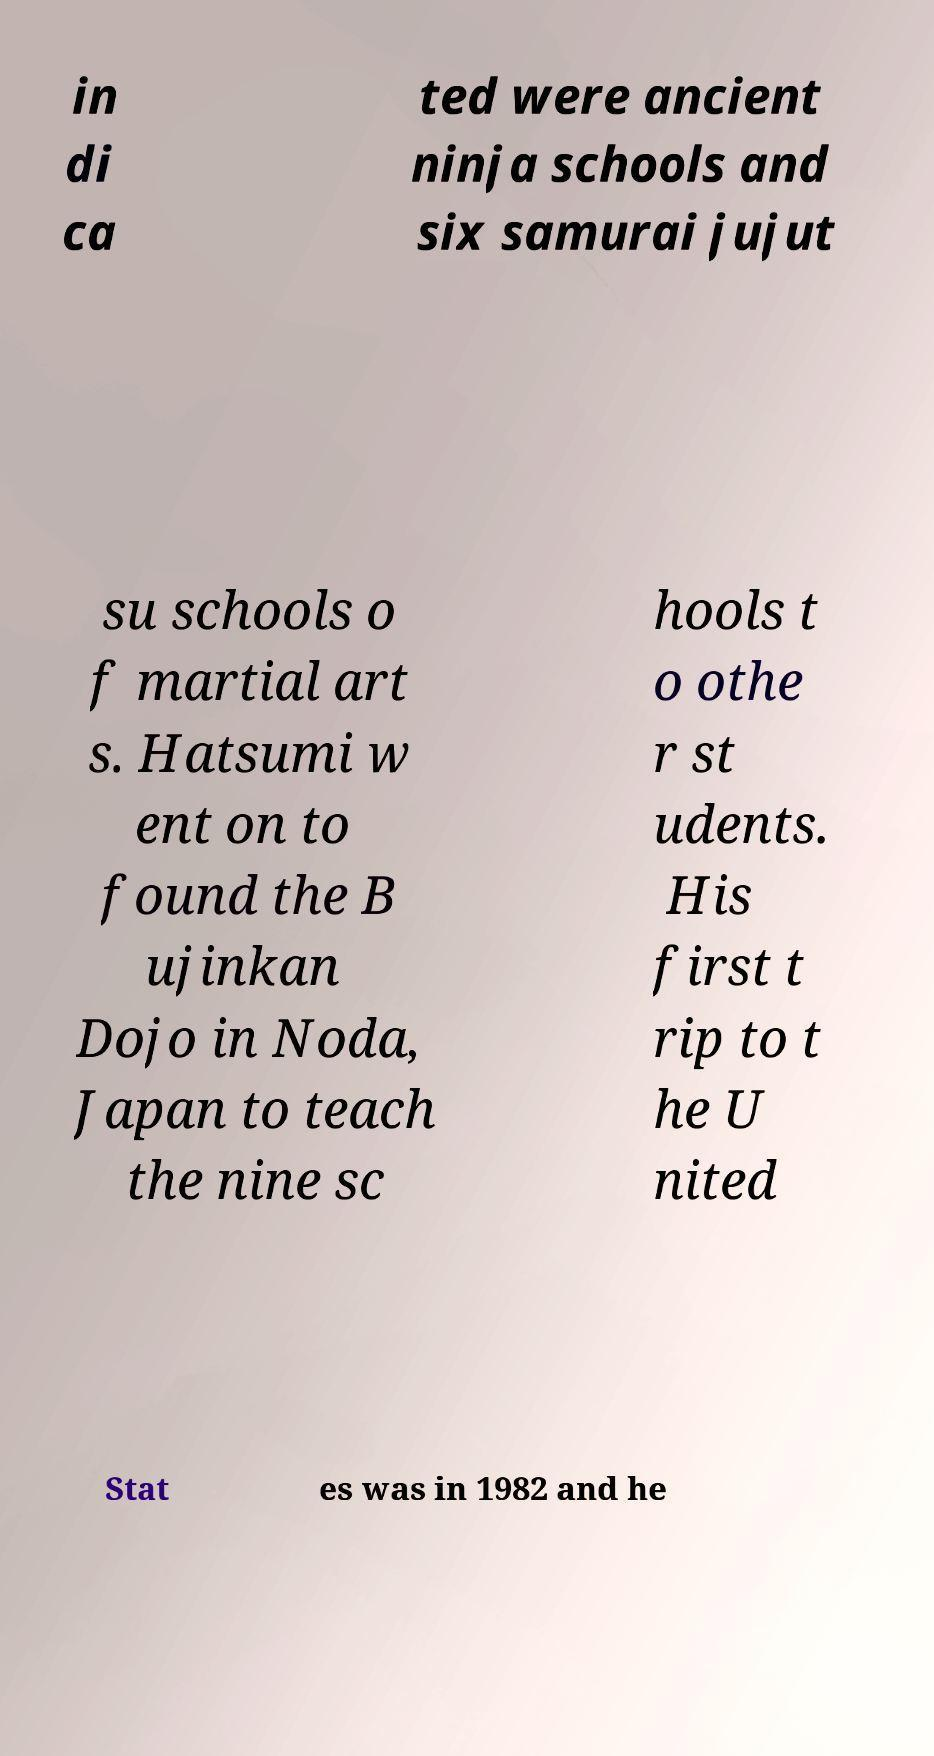There's text embedded in this image that I need extracted. Can you transcribe it verbatim? in di ca ted were ancient ninja schools and six samurai jujut su schools o f martial art s. Hatsumi w ent on to found the B ujinkan Dojo in Noda, Japan to teach the nine sc hools t o othe r st udents. His first t rip to t he U nited Stat es was in 1982 and he 